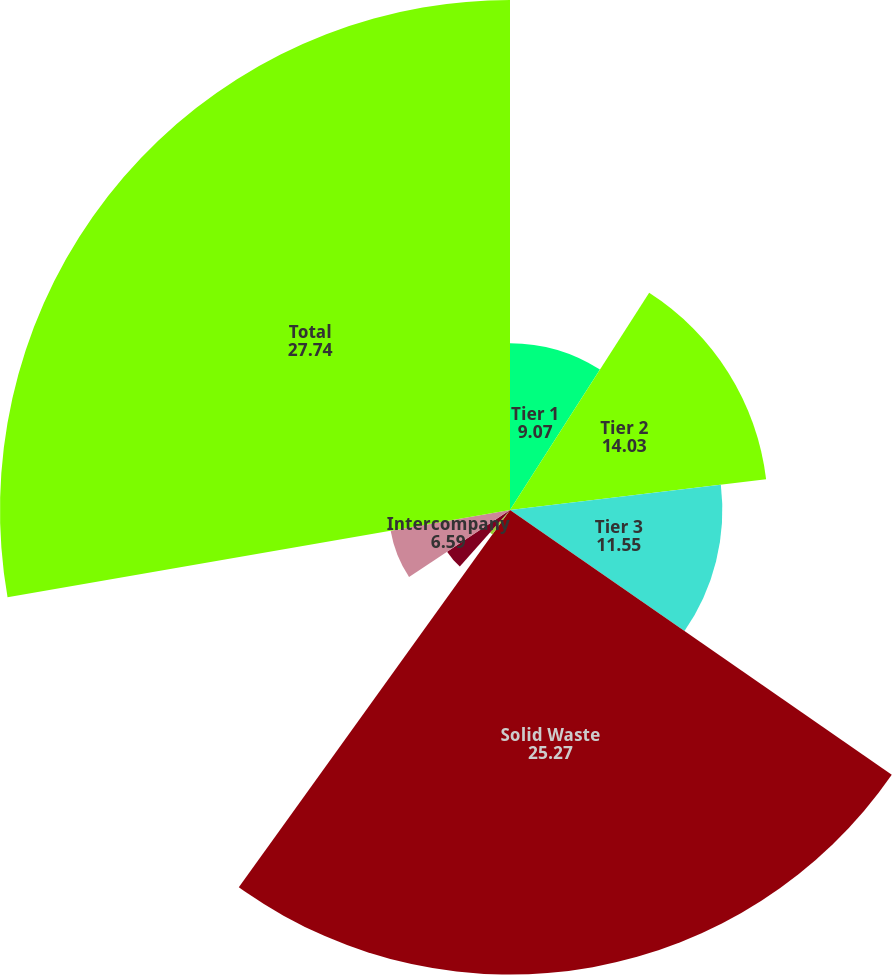Convert chart to OTSL. <chart><loc_0><loc_0><loc_500><loc_500><pie_chart><fcel>Tier 1<fcel>Tier 2<fcel>Tier 3<fcel>Solid Waste<fcel>Wheelabrator<fcel>Other<fcel>Intercompany<fcel>Total<nl><fcel>9.07%<fcel>14.03%<fcel>11.55%<fcel>25.27%<fcel>1.64%<fcel>4.11%<fcel>6.59%<fcel>27.74%<nl></chart> 